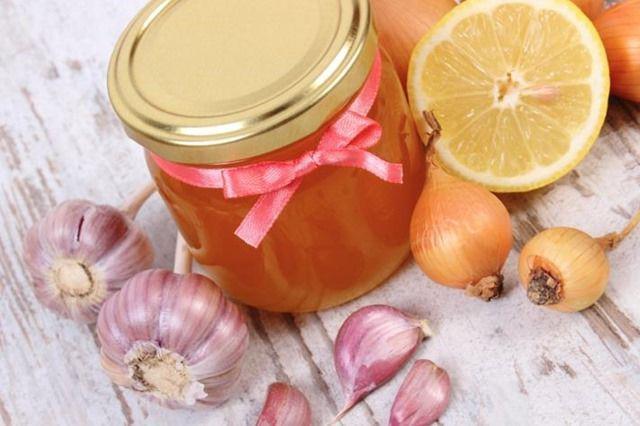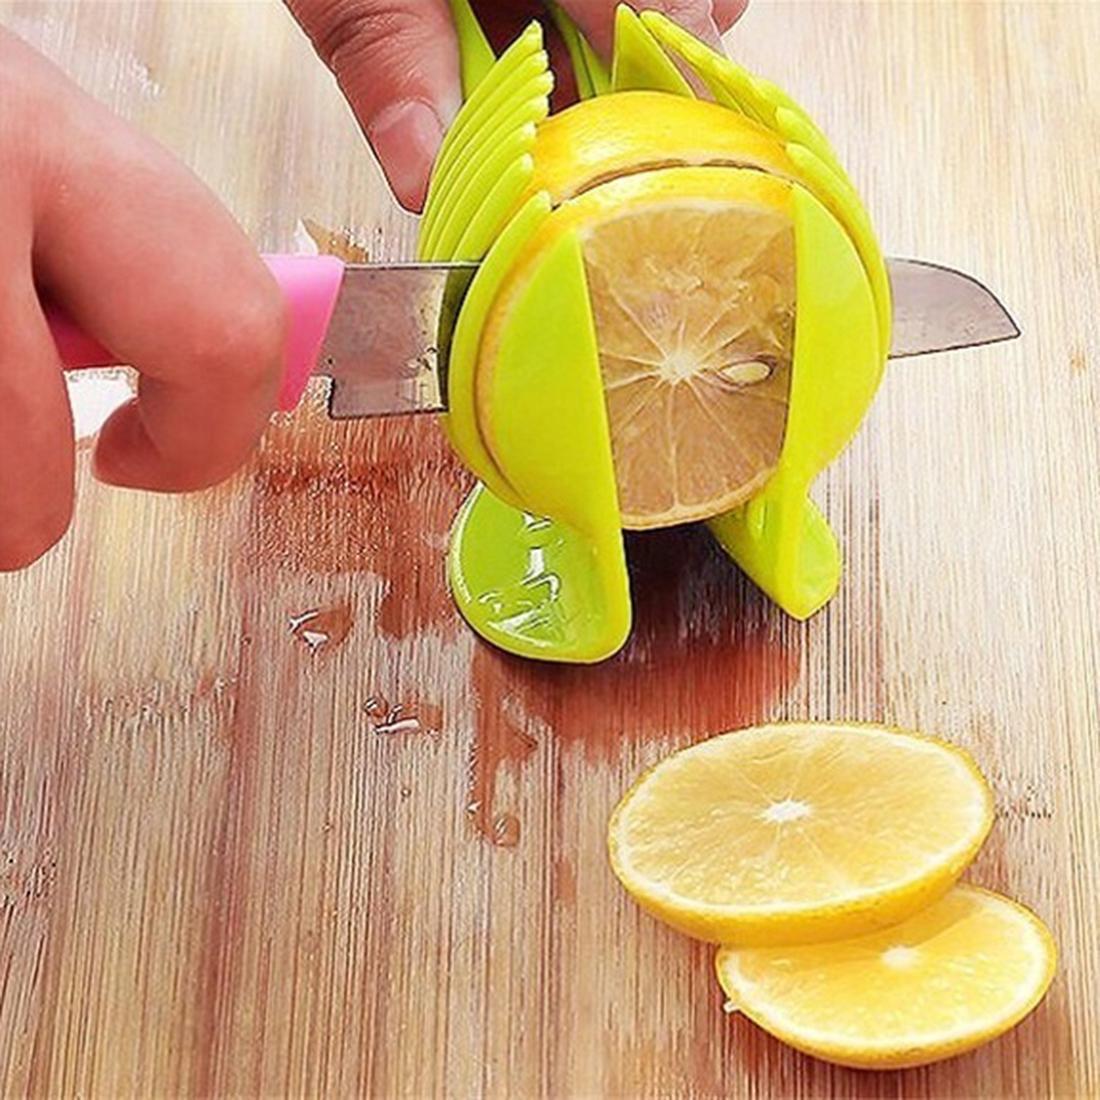The first image is the image on the left, the second image is the image on the right. Given the left and right images, does the statement "One picture has atleast 2 full cloves of garlic and 2 full onions" hold true? Answer yes or no. Yes. 